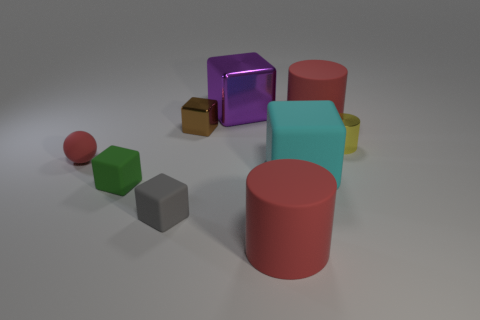Subtract all purple cubes. How many red cylinders are left? 2 Subtract all yellow cylinders. How many cylinders are left? 2 Subtract all green cubes. How many cubes are left? 4 Subtract 3 cubes. How many cubes are left? 2 Add 1 yellow things. How many objects exist? 10 Subtract all red blocks. Subtract all gray spheres. How many blocks are left? 5 Subtract all spheres. How many objects are left? 8 Add 6 big blocks. How many big blocks are left? 8 Add 6 tiny yellow objects. How many tiny yellow objects exist? 7 Subtract 0 purple cylinders. How many objects are left? 9 